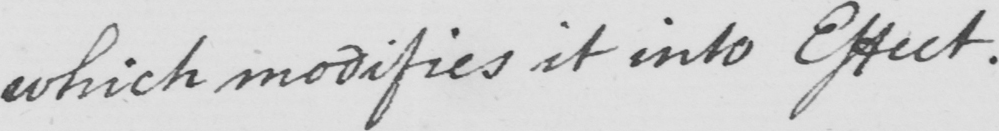What text is written in this handwritten line? which modifies it into Effect . 